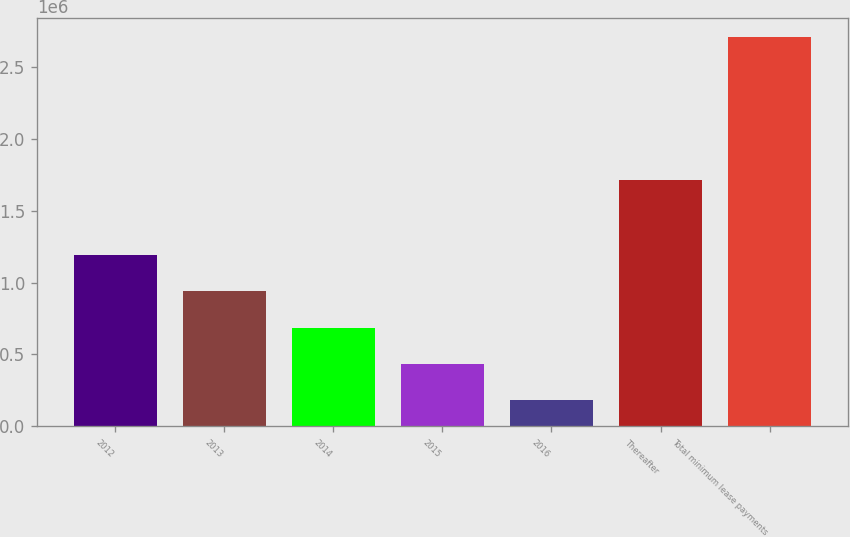Convert chart to OTSL. <chart><loc_0><loc_0><loc_500><loc_500><bar_chart><fcel>2012<fcel>2013<fcel>2014<fcel>2015<fcel>2016<fcel>Thereafter<fcel>Total minimum lease payments<nl><fcel>1.19211e+06<fcel>939271<fcel>686432<fcel>433592<fcel>180753<fcel>1.71426e+06<fcel>2.70915e+06<nl></chart> 